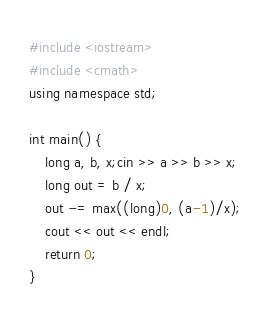<code> <loc_0><loc_0><loc_500><loc_500><_C++_>#include <iostream>
#include <cmath>
using namespace std;

int main() {
	long a, b, x;cin >> a >> b >> x;
	long out = b / x;
	out -= max((long)0, (a-1)/x);
	cout << out << endl;
	return 0;
}</code> 